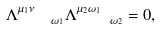<formula> <loc_0><loc_0><loc_500><loc_500>\Lambda _ { \quad \omega _ { 1 } } ^ { \mu _ { 1 } \nu } \Lambda _ { \quad \omega _ { 2 } } ^ { \mu _ { 2 } \omega _ { 1 } } = 0 ,</formula> 